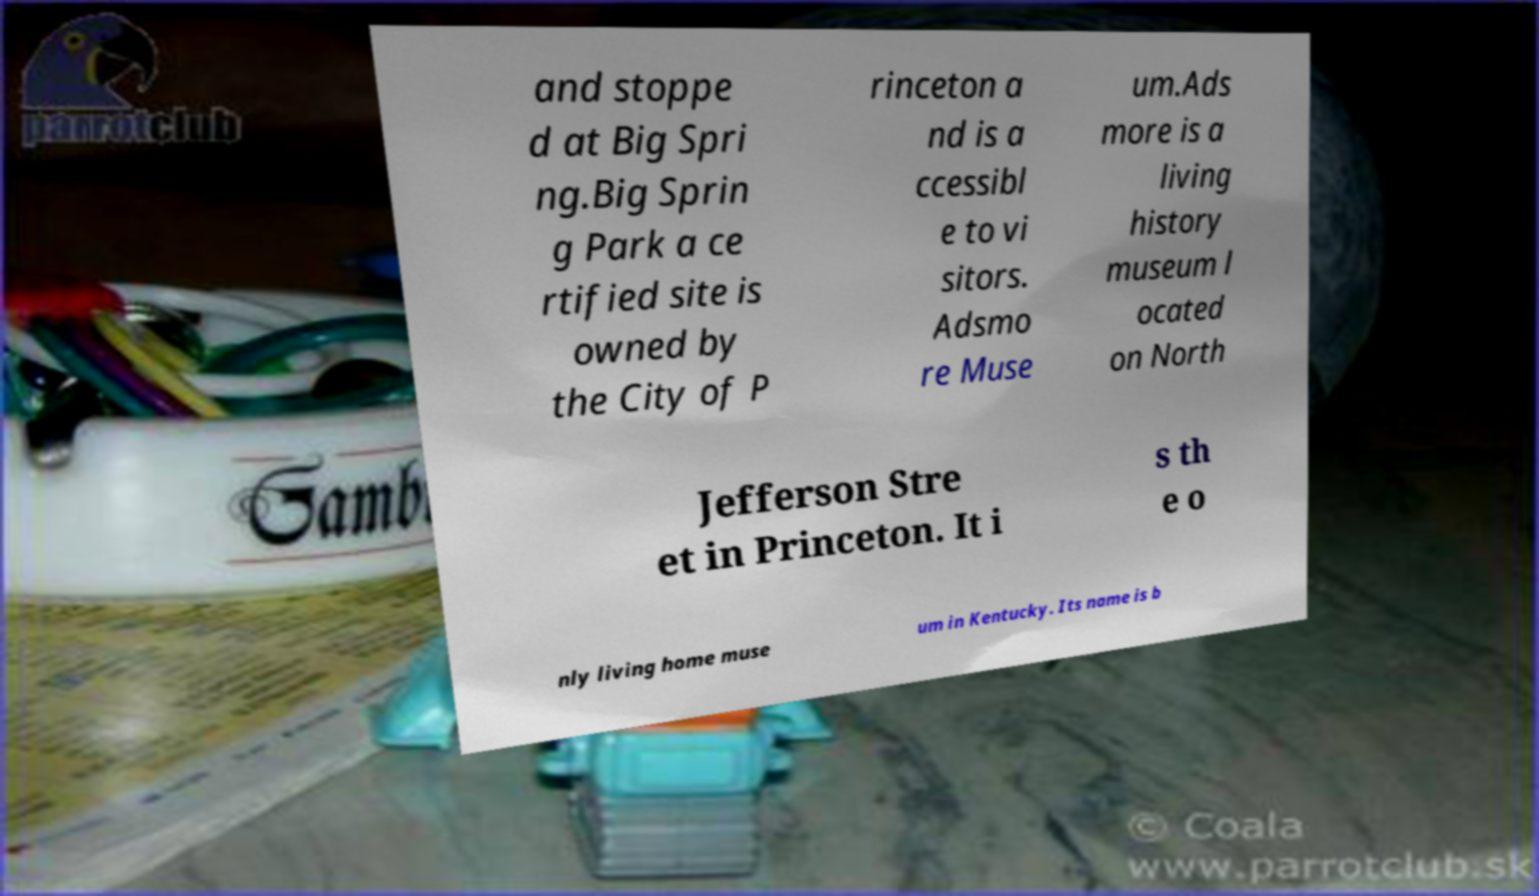Could you extract and type out the text from this image? and stoppe d at Big Spri ng.Big Sprin g Park a ce rtified site is owned by the City of P rinceton a nd is a ccessibl e to vi sitors. Adsmo re Muse um.Ads more is a living history museum l ocated on North Jefferson Stre et in Princeton. It i s th e o nly living home muse um in Kentucky. Its name is b 